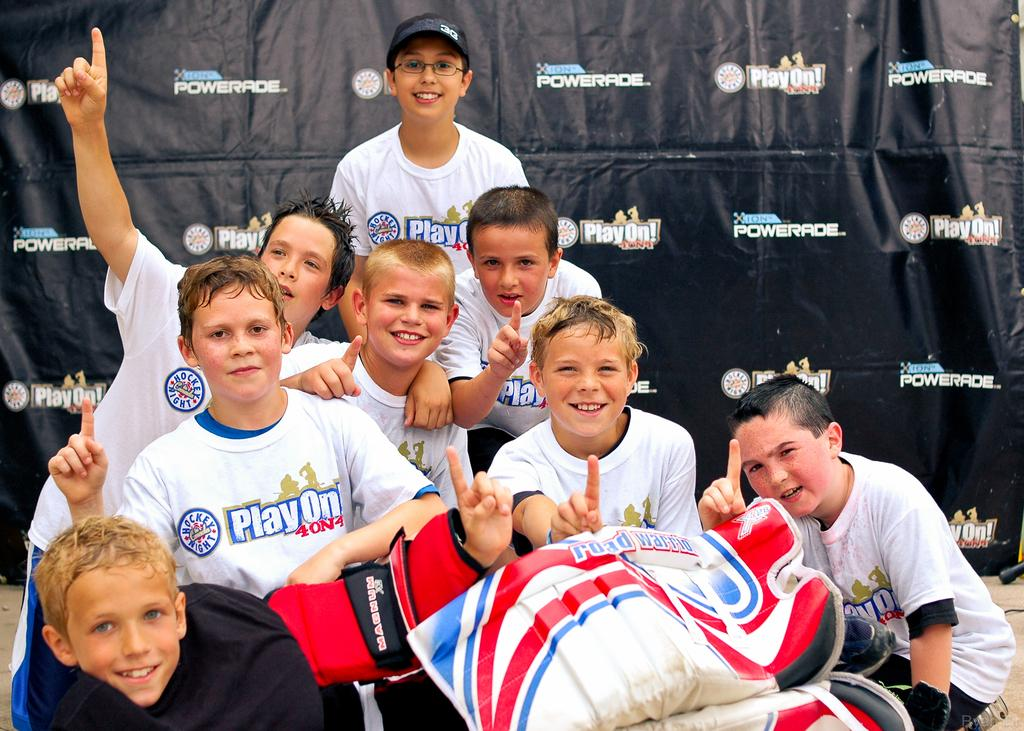<image>
Render a clear and concise summary of the photo. A group of children wearing PlayOn shirts pose in front of a Powerade backdrop. 